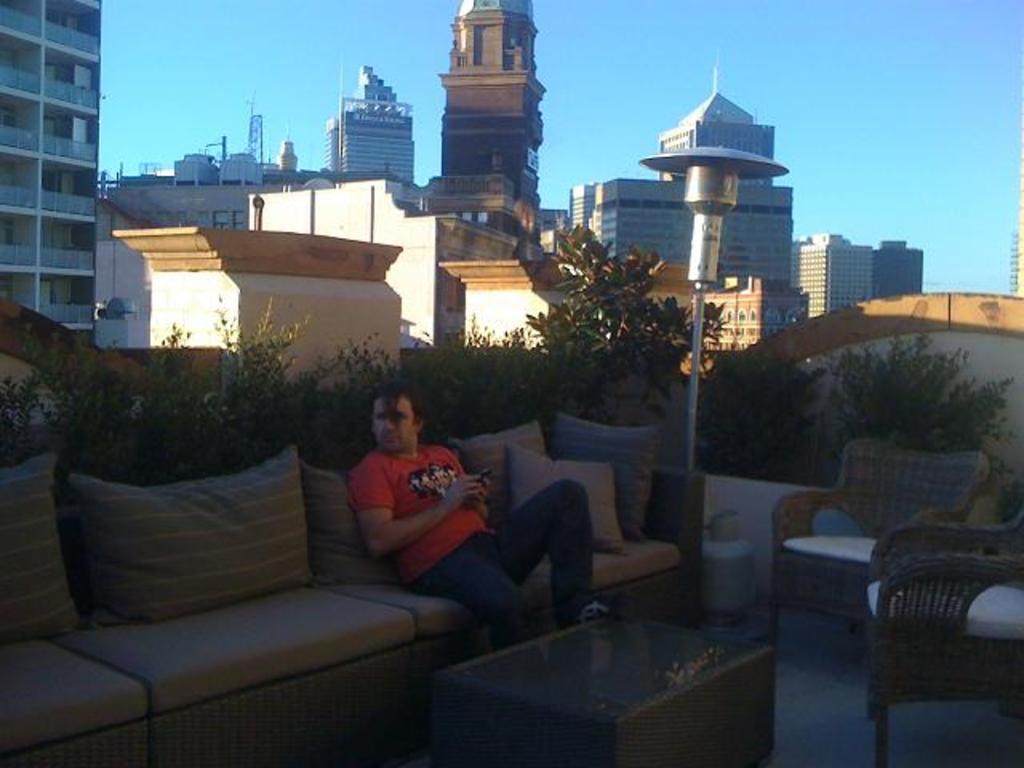In one or two sentences, can you explain what this image depicts? This image is taken on top of the building. There are sofas, pillows, chairs, table on the floor. A person wearing red T shirt, blue jeans is sitting on the sofa and holding a phone. There are some plants behind the sofas. In the background there are top buildings and blue sky. 